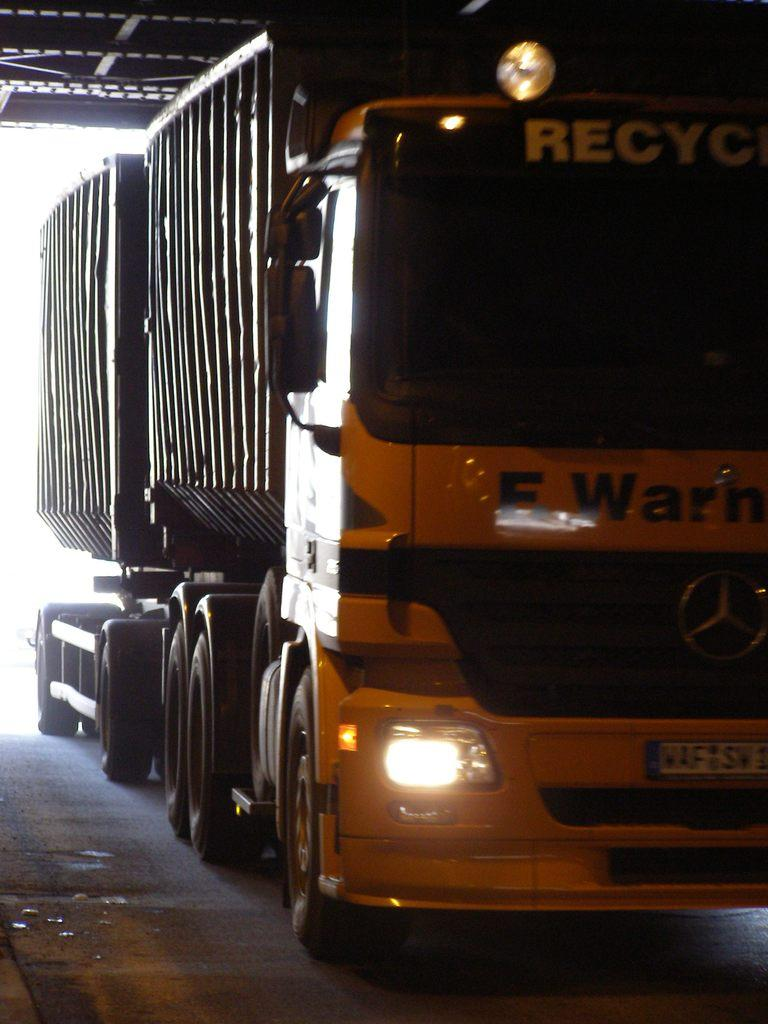What type of vehicle is in the image? There is a big goods vehicle in the image. Where is the goods vehicle located? The goods vehicle is on the floor. Is the goods vehicle protected from the elements in any way? Yes, the goods vehicle is under a roof shed. What is the value of the bath in the image? There is no bath present in the image, so it is not possible to determine its value. 